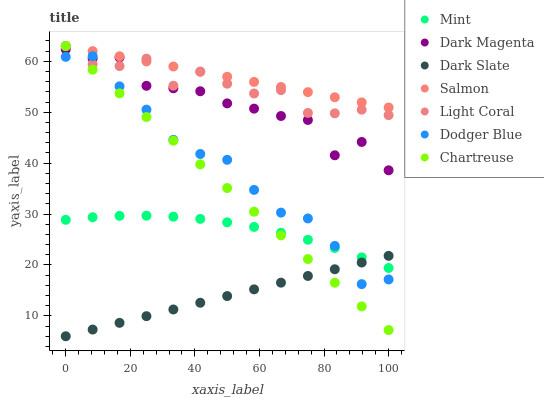Does Dark Slate have the minimum area under the curve?
Answer yes or no. Yes. Does Salmon have the maximum area under the curve?
Answer yes or no. Yes. Does Light Coral have the minimum area under the curve?
Answer yes or no. No. Does Light Coral have the maximum area under the curve?
Answer yes or no. No. Is Dark Slate the smoothest?
Answer yes or no. Yes. Is Dark Magenta the roughest?
Answer yes or no. Yes. Is Salmon the smoothest?
Answer yes or no. No. Is Salmon the roughest?
Answer yes or no. No. Does Dark Slate have the lowest value?
Answer yes or no. Yes. Does Light Coral have the lowest value?
Answer yes or no. No. Does Chartreuse have the highest value?
Answer yes or no. Yes. Does Dark Slate have the highest value?
Answer yes or no. No. Is Dark Slate less than Light Coral?
Answer yes or no. Yes. Is Salmon greater than Dodger Blue?
Answer yes or no. Yes. Does Dodger Blue intersect Dark Magenta?
Answer yes or no. Yes. Is Dodger Blue less than Dark Magenta?
Answer yes or no. No. Is Dodger Blue greater than Dark Magenta?
Answer yes or no. No. Does Dark Slate intersect Light Coral?
Answer yes or no. No. 